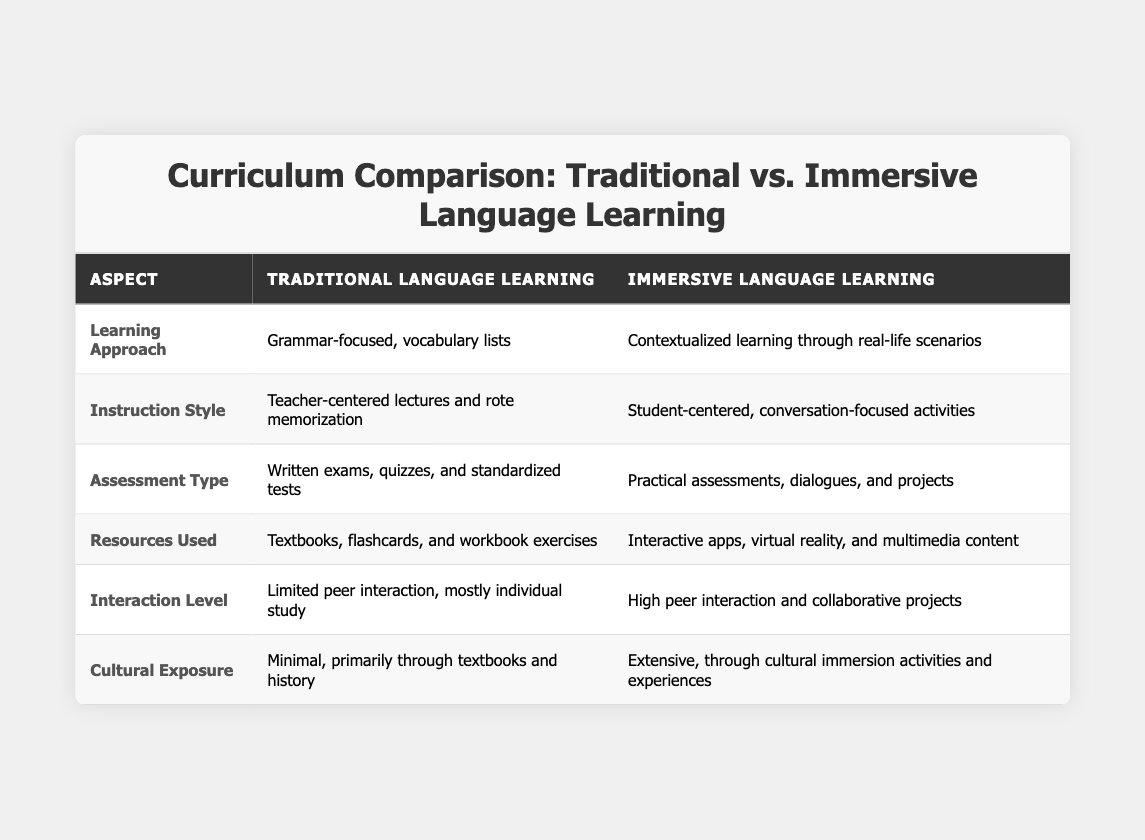What is the main focus of the "Traditional Language Learning" approach? The table indicates that the "Traditional Language Learning" approach focuses on a grammar-centric method which emphasizes vocabulary lists.
Answer: Grammar-focused, vocabulary lists How are assessments conducted in "Immersive Language Learning"? According to the table, assessments in "Immersive Language Learning" are practical and include dialogues and projects, rather than standard written tests.
Answer: Practical assessments, dialogues, and projects Does "Traditional Language Learning" involve high peer interaction? The table states that peer interaction in "Traditional Language Learning" is limited and mostly consists of individual study, indicating a low level of interaction.
Answer: No Which method uses interactive apps as resources? The table highlights that "Immersive Language Learning" utilizes interactive apps and multimedia content, while "Traditional Language Learning" primarily uses textbooks and flashcards.
Answer: Immersive Language Learning What are the main differences in Cultural Exposure between the two methods? The data shows that "Traditional Language Learning" provides minimal cultural exposure through textbooks, while "Immersive Language Learning" offers extensive exposure through immersive experiences.
Answer: "Traditional" has minimal, "Immersive" has extensive In which method is the instruction style more student-centered? The table shows that the instruction style is student-centered in "Immersive Language Learning", contrasting with the teacher-centered lectures in "Traditional Language Learning".
Answer: Immersive Language Learning Summarize the resources used in both methods. "Traditional Language Learning" uses textbooks, flashcards, and workbooks, while "Immersive Language Learning" employs interactive apps, virtual reality, and multimedia content, indicating a stark contrast.
Answer: Traditional: Textbooks, Immersive: Apps and VR How does the assessment type differ between both learning methods? The assessments of "Traditional Language Learning" consist of written exams and standardized tests, whereas "Immersive Language Learning" focuses on practical assessments and projects, showing a clear difference in evaluation strategy.
Answer: Traditional: Written exams, Immersive: Practical assessments What aspect of learning does "Immersive Language Learning" emphasize more than "Traditional Language Learning"? "Immersive Language Learning" emphasizes contextualized learning through real-life scenarios as opposed to the grammar-focused approach found in traditional methods.
Answer: Contextualized learning through real-life scenarios If a student prefers active participation in learning, which method would be more suitable? Based on the table, "Immersive Language Learning" involves high peer interaction and collaborative projects, making it more suitable for students who prefer active participation.
Answer: Immersive Language Learning Can we conclude that "Immersive Language Learning" offers more cultural exposure than "Traditional Language Learning"? The table directly states that "Immersive Language Learning" provides extensive cultural exposure through activities, while "Traditional Language Learning" provides minimal exposure, validating the conclusion.
Answer: Yes 